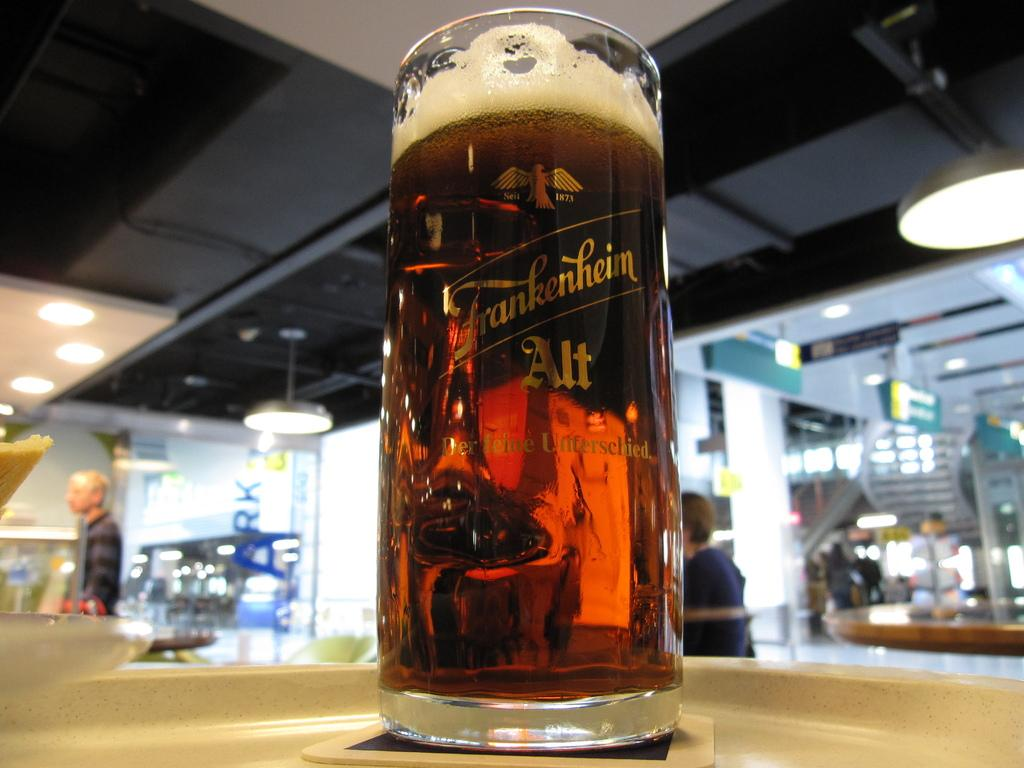<image>
Describe the image concisely. A glass bears the name Frankenheim on it. 